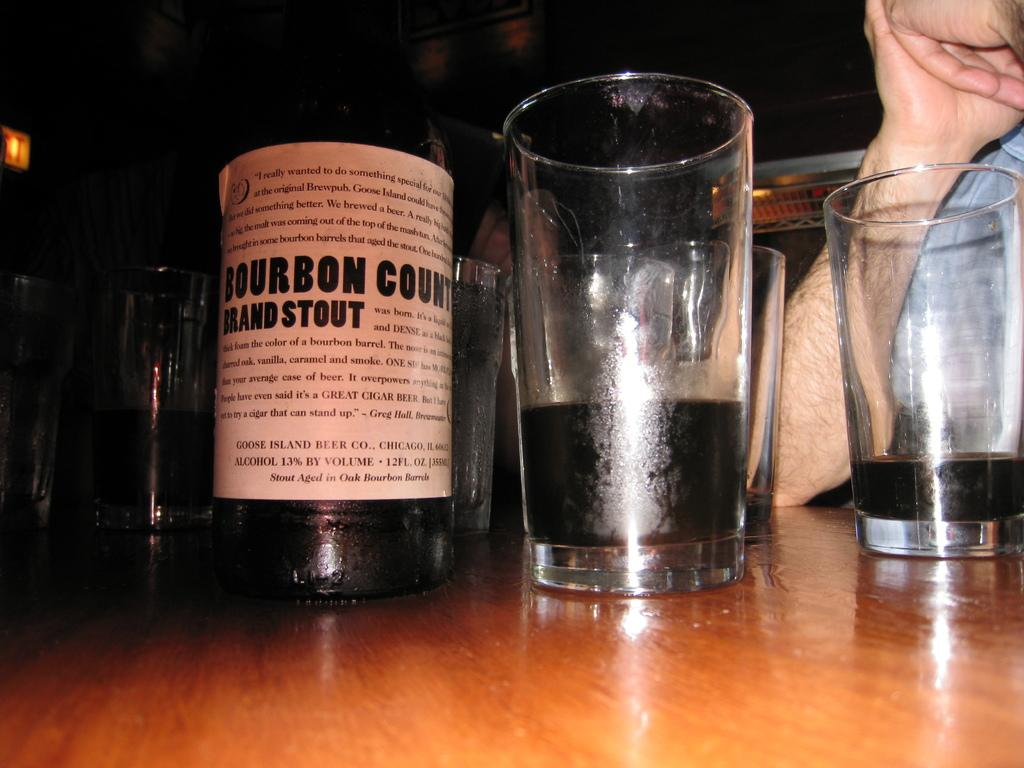What objects are present in the image that are typically used for drinking? There are glasses in the image. What can be seen on the table in the image? There is an alcohol bottle on a table in the image. Whose hand is visible in the image? A hand of a person is visible in the image. What type of ear is visible in the image? There is no ear visible in the image. Is there a lawyer present in the image? There is no indication of a lawyer being present in the image. 